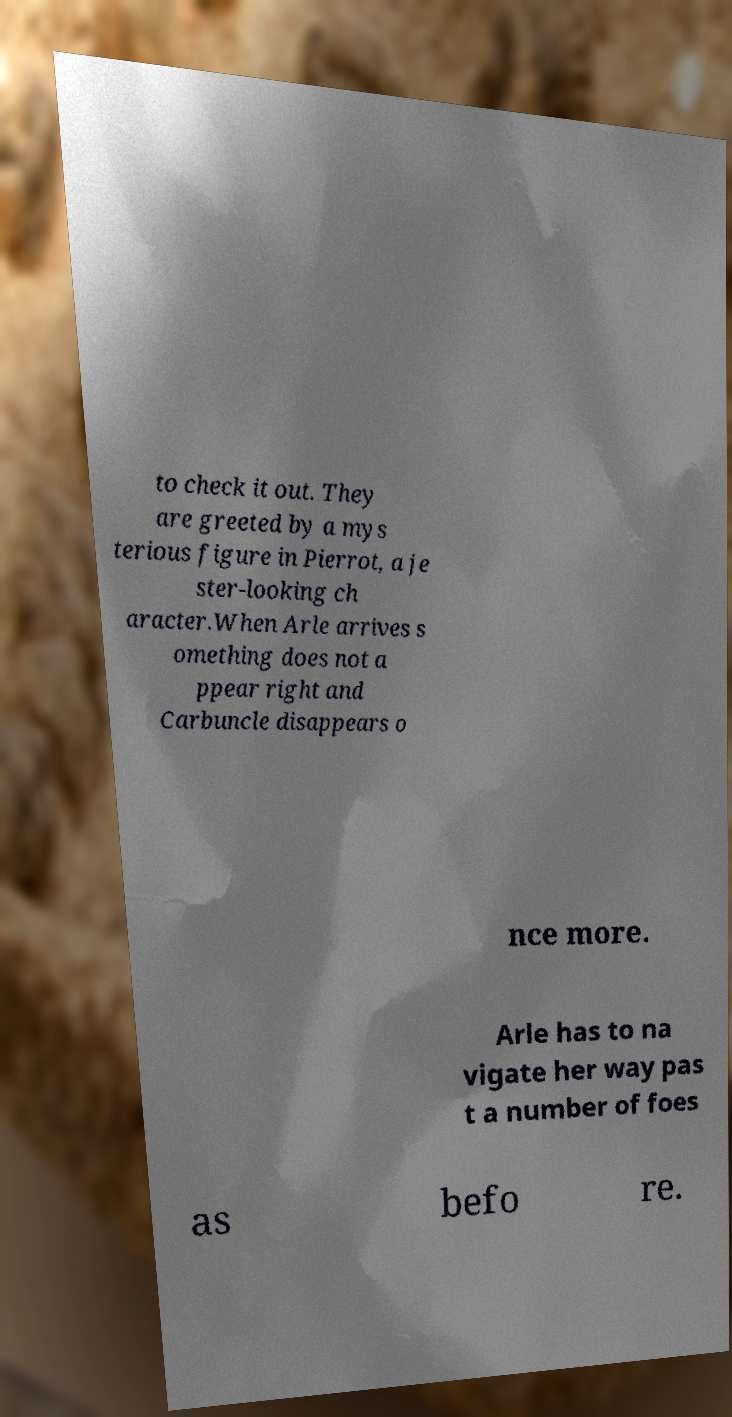Could you extract and type out the text from this image? to check it out. They are greeted by a mys terious figure in Pierrot, a je ster-looking ch aracter.When Arle arrives s omething does not a ppear right and Carbuncle disappears o nce more. Arle has to na vigate her way pas t a number of foes as befo re. 